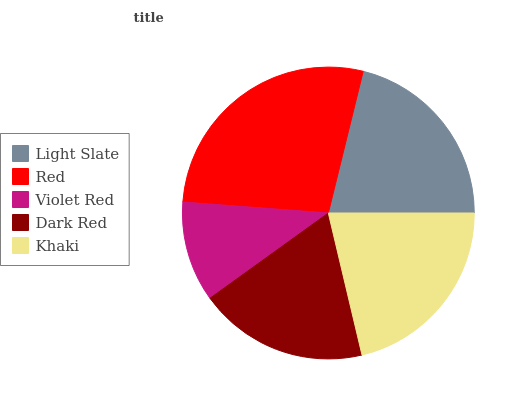Is Violet Red the minimum?
Answer yes or no. Yes. Is Red the maximum?
Answer yes or no. Yes. Is Red the minimum?
Answer yes or no. No. Is Violet Red the maximum?
Answer yes or no. No. Is Red greater than Violet Red?
Answer yes or no. Yes. Is Violet Red less than Red?
Answer yes or no. Yes. Is Violet Red greater than Red?
Answer yes or no. No. Is Red less than Violet Red?
Answer yes or no. No. Is Light Slate the high median?
Answer yes or no. Yes. Is Light Slate the low median?
Answer yes or no. Yes. Is Red the high median?
Answer yes or no. No. Is Dark Red the low median?
Answer yes or no. No. 